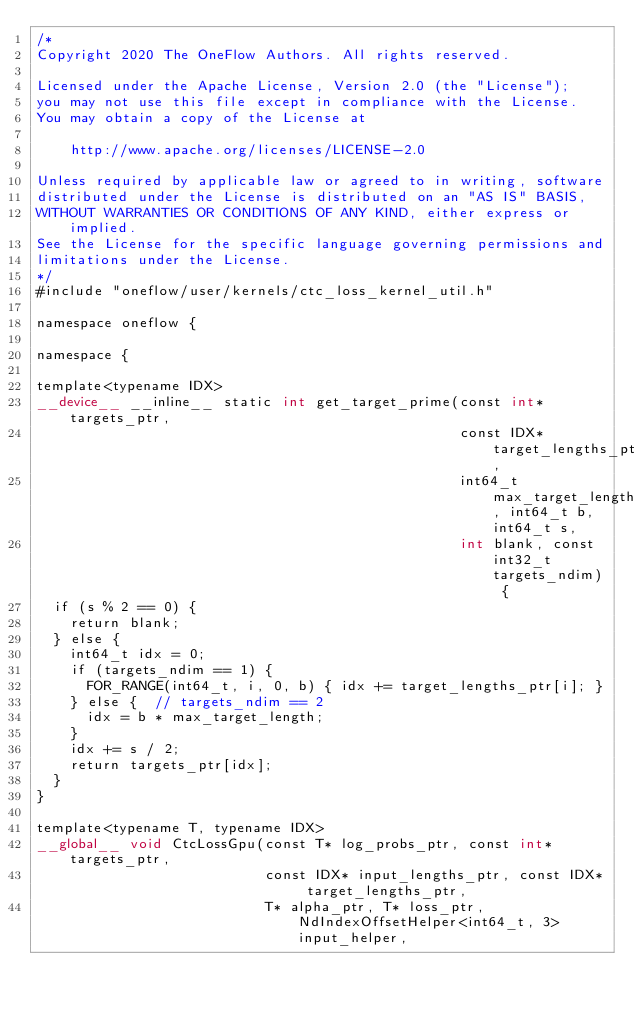<code> <loc_0><loc_0><loc_500><loc_500><_Cuda_>/*
Copyright 2020 The OneFlow Authors. All rights reserved.

Licensed under the Apache License, Version 2.0 (the "License");
you may not use this file except in compliance with the License.
You may obtain a copy of the License at

    http://www.apache.org/licenses/LICENSE-2.0

Unless required by applicable law or agreed to in writing, software
distributed under the License is distributed on an "AS IS" BASIS,
WITHOUT WARRANTIES OR CONDITIONS OF ANY KIND, either express or implied.
See the License for the specific language governing permissions and
limitations under the License.
*/
#include "oneflow/user/kernels/ctc_loss_kernel_util.h"

namespace oneflow {

namespace {

template<typename IDX>
__device__ __inline__ static int get_target_prime(const int* targets_ptr,
                                                  const IDX* target_lengths_ptr,
                                                  int64_t max_target_length, int64_t b, int64_t s,
                                                  int blank, const int32_t targets_ndim) {
  if (s % 2 == 0) {
    return blank;
  } else {
    int64_t idx = 0;
    if (targets_ndim == 1) {
      FOR_RANGE(int64_t, i, 0, b) { idx += target_lengths_ptr[i]; }
    } else {  // targets_ndim == 2
      idx = b * max_target_length;
    }
    idx += s / 2;
    return targets_ptr[idx];
  }
}

template<typename T, typename IDX>
__global__ void CtcLossGpu(const T* log_probs_ptr, const int* targets_ptr,
                           const IDX* input_lengths_ptr, const IDX* target_lengths_ptr,
                           T* alpha_ptr, T* loss_ptr, NdIndexOffsetHelper<int64_t, 3> input_helper,</code> 